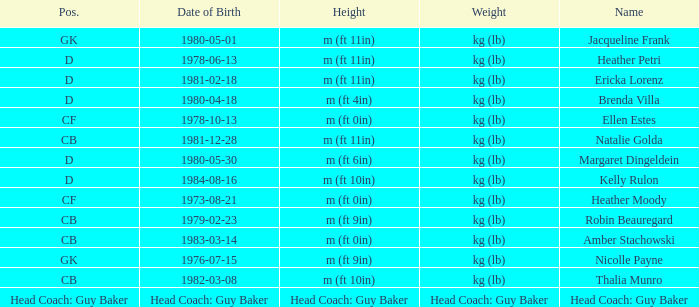Could you help me parse every detail presented in this table? {'header': ['Pos.', 'Date of Birth', 'Height', 'Weight', 'Name'], 'rows': [['GK', '1980-05-01', 'm (ft 11in)', 'kg (lb)', 'Jacqueline Frank'], ['D', '1978-06-13', 'm (ft 11in)', 'kg (lb)', 'Heather Petri'], ['D', '1981-02-18', 'm (ft 11in)', 'kg (lb)', 'Ericka Lorenz'], ['D', '1980-04-18', 'm (ft 4in)', 'kg (lb)', 'Brenda Villa'], ['CF', '1978-10-13', 'm (ft 0in)', 'kg (lb)', 'Ellen Estes'], ['CB', '1981-12-28', 'm (ft 11in)', 'kg (lb)', 'Natalie Golda'], ['D', '1980-05-30', 'm (ft 6in)', 'kg (lb)', 'Margaret Dingeldein'], ['D', '1984-08-16', 'm (ft 10in)', 'kg (lb)', 'Kelly Rulon'], ['CF', '1973-08-21', 'm (ft 0in)', 'kg (lb)', 'Heather Moody'], ['CB', '1979-02-23', 'm (ft 9in)', 'kg (lb)', 'Robin Beauregard'], ['CB', '1983-03-14', 'm (ft 0in)', 'kg (lb)', 'Amber Stachowski'], ['GK', '1976-07-15', 'm (ft 9in)', 'kg (lb)', 'Nicolle Payne'], ['CB', '1982-03-08', 'm (ft 10in)', 'kg (lb)', 'Thalia Munro'], ['Head Coach: Guy Baker', 'Head Coach: Guy Baker', 'Head Coach: Guy Baker', 'Head Coach: Guy Baker', 'Head Coach: Guy Baker']]} Born on 1983-03-14, what is the cb's name? Amber Stachowski. 